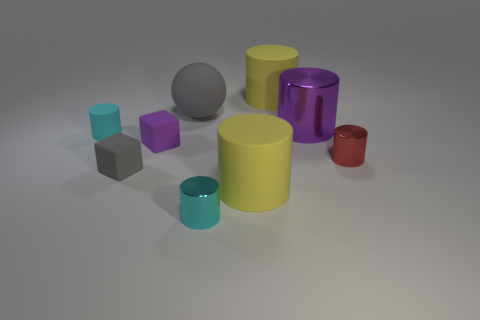How many yellow metallic cylinders are the same size as the gray block?
Make the answer very short. 0. What is the shape of the small matte thing that is in front of the red cylinder that is right of the gray rubber ball?
Provide a succinct answer. Cube. Are there fewer big objects than tiny gray rubber things?
Make the answer very short. No. What color is the matte cube in front of the small red cylinder?
Your answer should be compact. Gray. What is the small cylinder that is on the right side of the tiny gray matte block and on the left side of the red cylinder made of?
Offer a terse response. Metal. The small object that is made of the same material as the small red cylinder is what shape?
Provide a succinct answer. Cylinder. There is a gray object behind the big purple metallic cylinder; how many matte objects are right of it?
Keep it short and to the point. 2. What number of things are both right of the purple shiny cylinder and behind the big gray object?
Provide a short and direct response. 0. What number of other things are there of the same material as the big gray ball
Your answer should be very brief. 5. What is the color of the large cylinder behind the gray thing on the right side of the gray rubber block?
Ensure brevity in your answer.  Yellow. 